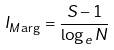<formula> <loc_0><loc_0><loc_500><loc_500>I _ { M \arg } = \frac { S - 1 } { \log _ { e } N }</formula> 